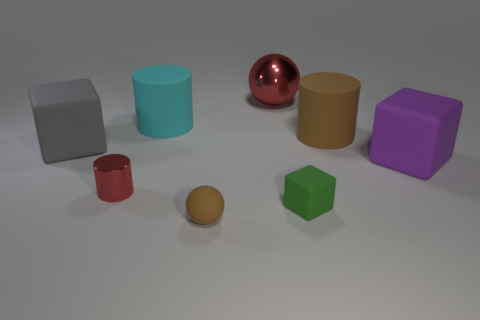Subtract 1 blocks. How many blocks are left? 2 Subtract all matte cylinders. How many cylinders are left? 1 Add 1 big cubes. How many objects exist? 9 Subtract all cylinders. How many objects are left? 5 Add 3 small purple cubes. How many small purple cubes exist? 3 Subtract 1 brown balls. How many objects are left? 7 Subtract all gray things. Subtract all big gray balls. How many objects are left? 7 Add 4 tiny matte things. How many tiny matte things are left? 6 